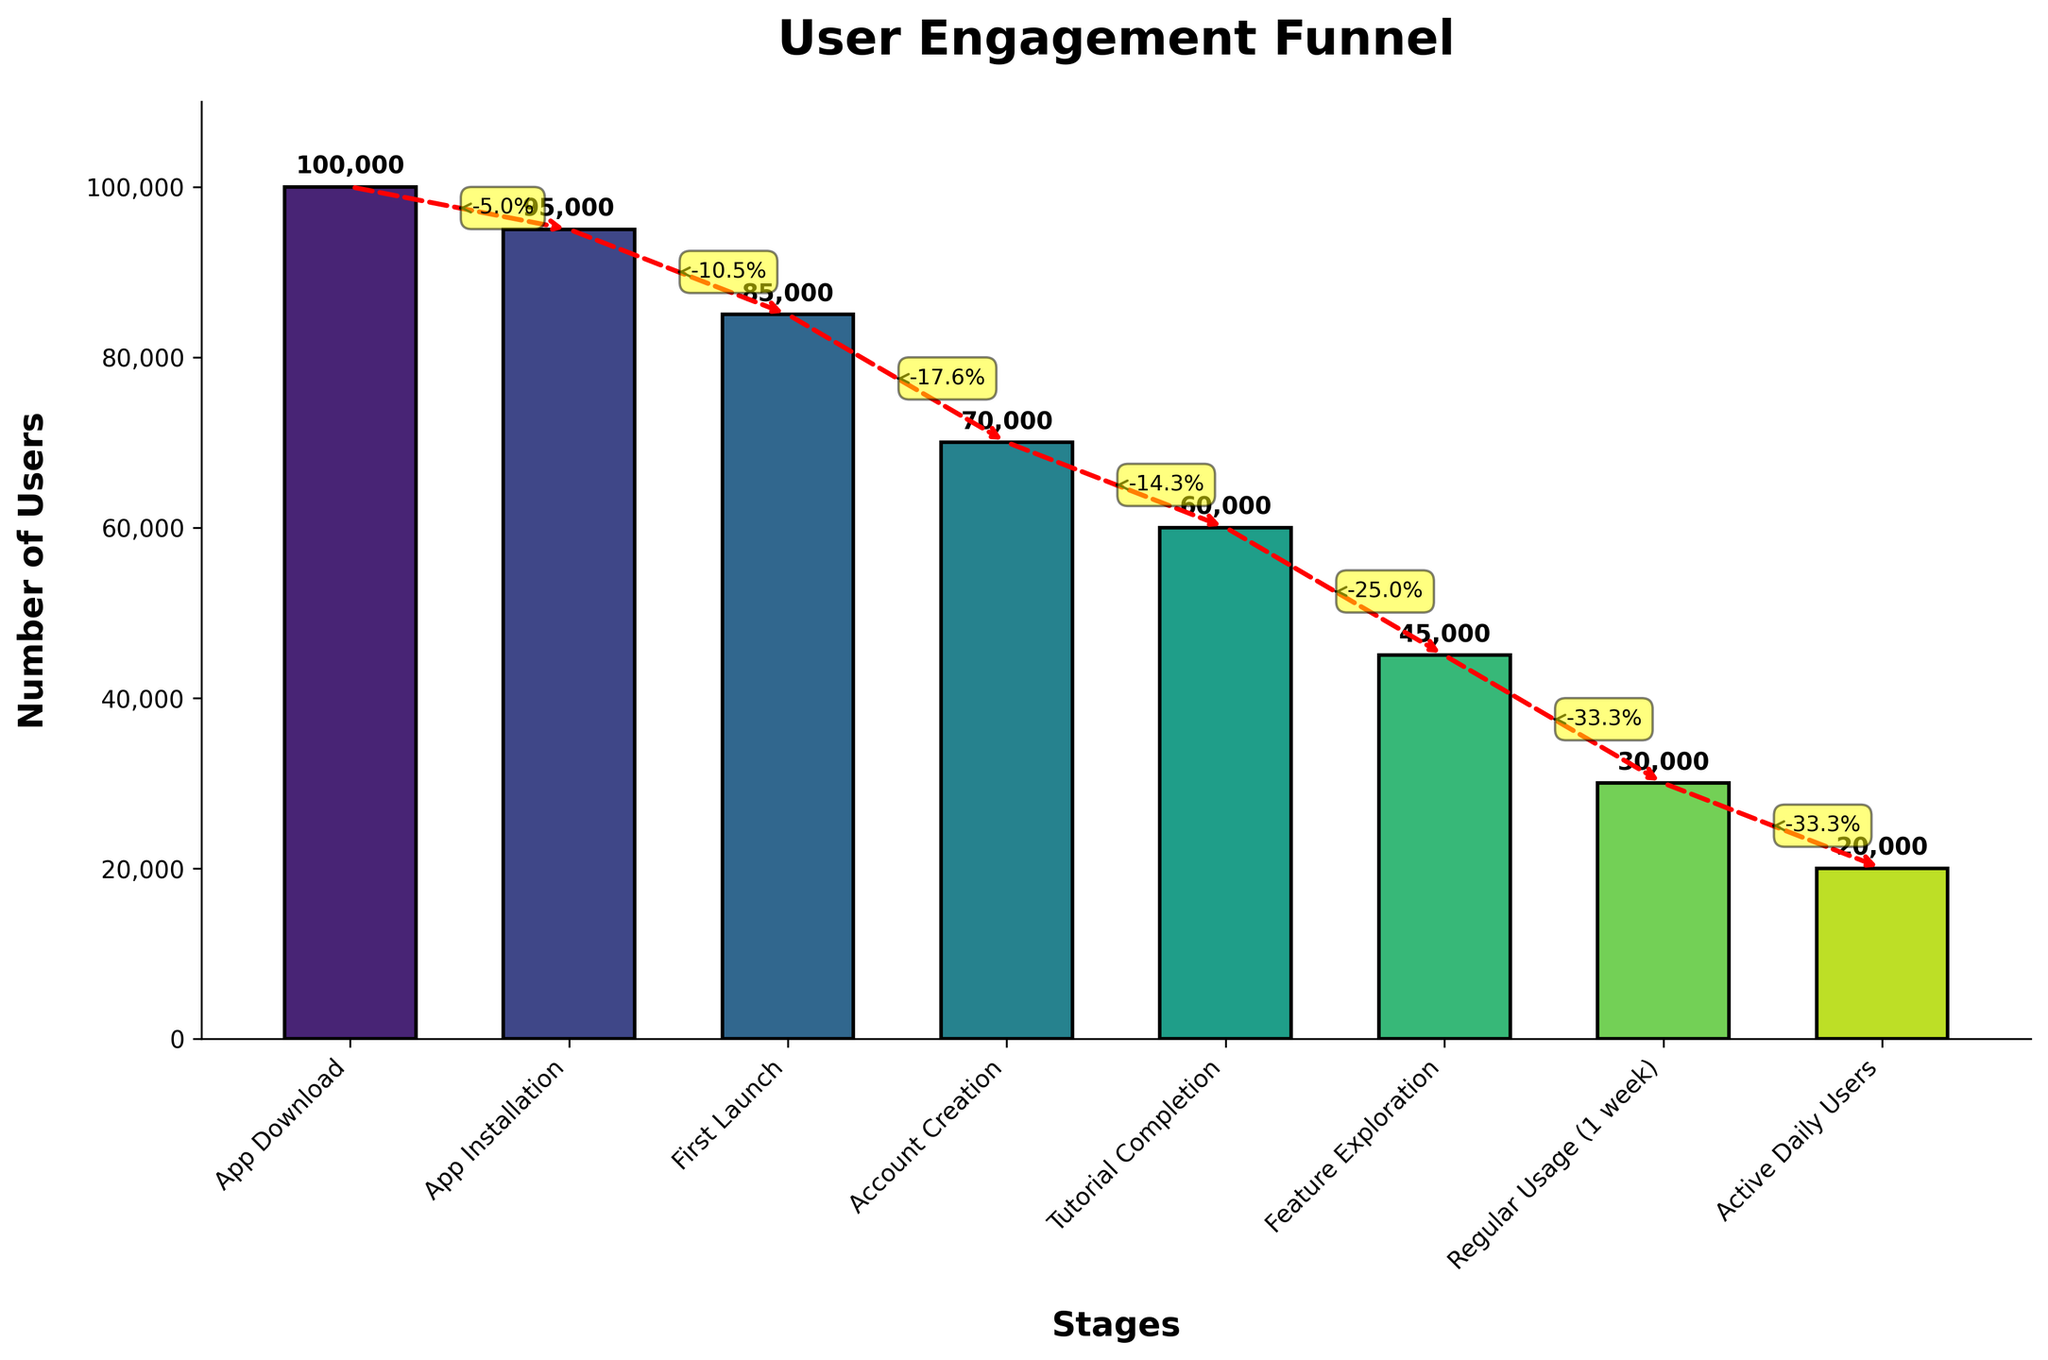Which stage has the highest number of users? The stage with the highest bar on the plot is "App Download," which has 100,000 users.
Answer: App Download What is the difference in user count between "App Download" and "Active Daily Users"? The user count for "App Download" is 100,000 and for "Active Daily Users" is 20,000. Subtracting these gives 100,000 - 20,000.
Answer: 80,000 At which stage is there the largest drop in user count? The largest drop in user count can be identified by the steepest decline in the bars or the largest percentage decrease annotated by the arrows. Comparing all stages, the drop from "Feature Exploration" to "Regular Usage (1 week)" is the largest.
Answer: Feature Exploration to Regular Usage (1 week) How many users completed the tutorial? The number of users who completed the tutorial is represented by the bar for "Tutorial Completion," which is 60,000 users.
Answer: 60,000 What percentage of users who created an account also completed the tutorial? The number of users who created an account is 70,000, and the number that completed the tutorial is 60,000. The percentage is calculated as (60,000 / 70,000) * 100 = 85.7%.
Answer: 85.7% Which stage had fewer users than "Feature Exploration"? "Regular Usage (1 week)" and "Active Daily Users" had fewer users than "Feature Exploration," which has 45,000 users.
Answer: Regular Usage (1 week) and Active Daily Users What is the user retention from the first launch to regular usage after 1 week? The number of users at "First Launch" is 85,000 and at "Regular Usage (1 week)" is 30,000. Retention percentage is calculated as (30,000 / 85,000) * 100 = 35.3%.
Answer: 35.3% How many users are lost between each consecutive stage? The losses between stages can be calculated by subtracting the number of users at each stage from the previous stage:  
- From "App Download" to "App Installation": 100,000 - 95,000 = 5,000
- From "App Installation" to "First Launch": 95,000 - 85,000 = 10,000
- From "First Launch" to "Account Creation": 85,000 - 70,000 = 15,000
- From "Account Creation" to "Tutorial Completion": 70,000 - 60,000 = 10,000
- From "Tutorial Completion" to "Feature Exploration": 60,000 - 45,000 = 15,000
- From "Feature Exploration" to "Regular Usage (1 week)": 45,000 - 30,000 = 15,000
- From "Regular Usage (1 week)" to "Active Daily Users": 30,000 - 20,000 = 10,000
Answer: 5,000, 10,000, 15,000, 10,000, 15,000, 15,000, 10,000 What stage has the narrowest funnel segment following it? The narrowest segment can be identified by the smallest percentage decrease represented by the deltas. The smallest percentage decrease occurs from "Tutorial Completion" to "Feature Exploration," marked as -25%.
Answer: Tutorial Completion to Feature Exploration 